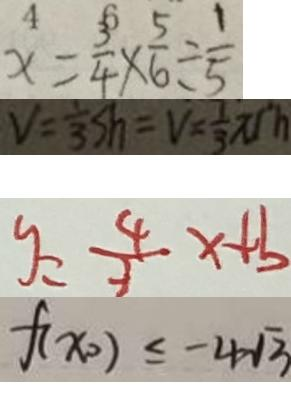<formula> <loc_0><loc_0><loc_500><loc_500>x = \frac { 3 } { 4 } \times \frac { 5 } { 6 } \div \frac { 1 } { 5 } 
 V = \frac { 1 } { 3 } s h = V = \frac { 1 } { 3 } \pi r h 
 y = \frac { 4 } { 3 } x + b 
 f ( x _ { 0 } ) \leq - 4 \sqrt { 3 }</formula> 